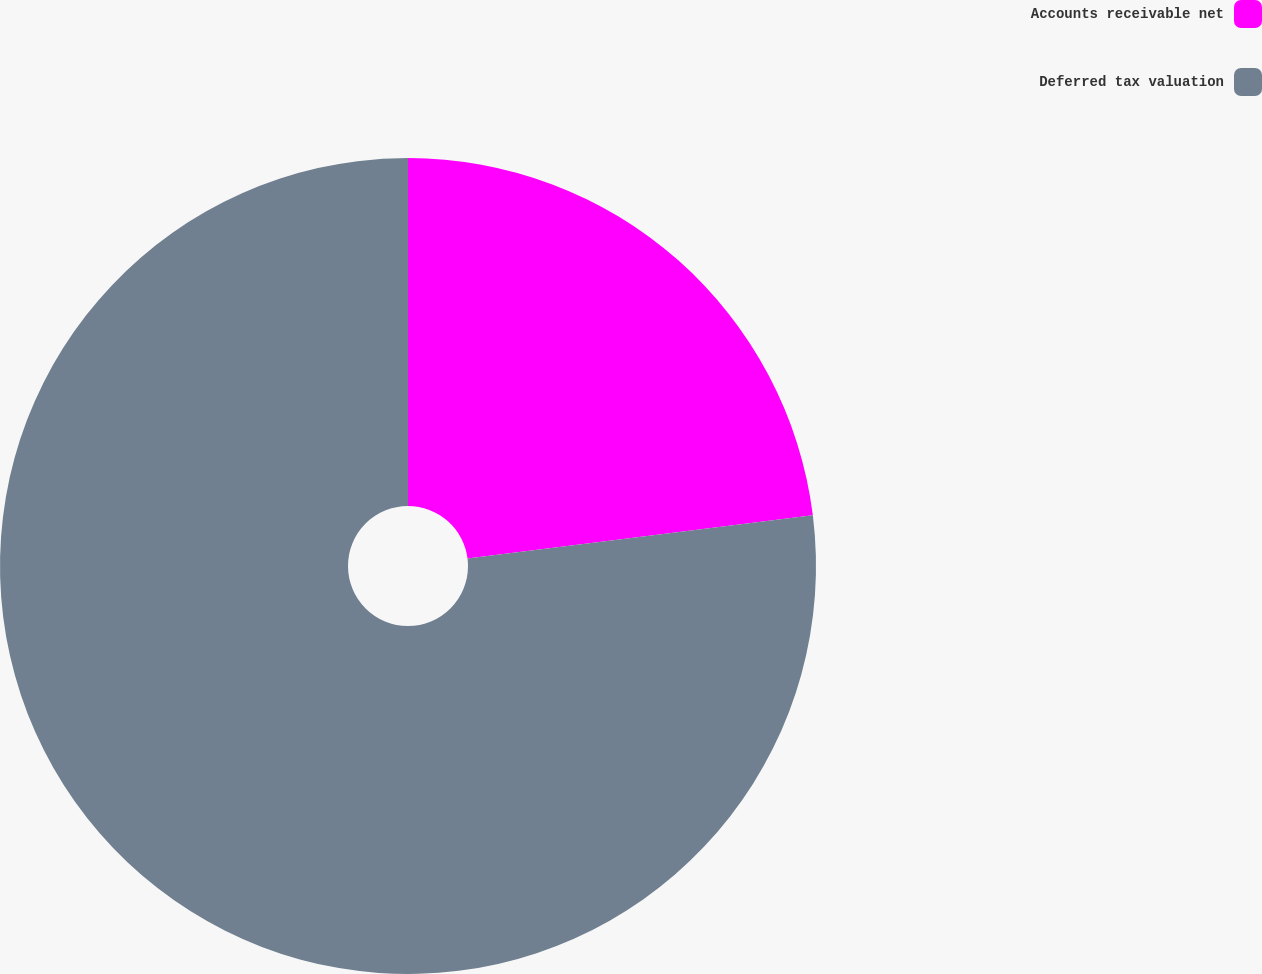<chart> <loc_0><loc_0><loc_500><loc_500><pie_chart><fcel>Accounts receivable net<fcel>Deferred tax valuation<nl><fcel>23.02%<fcel>76.98%<nl></chart> 